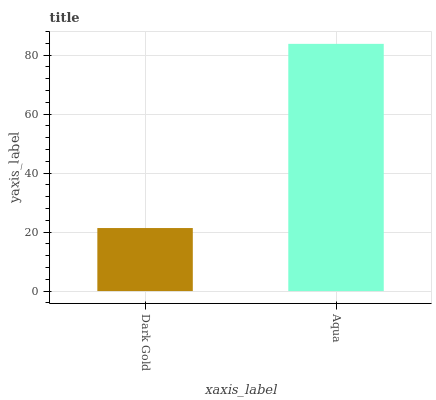Is Dark Gold the minimum?
Answer yes or no. Yes. Is Aqua the maximum?
Answer yes or no. Yes. Is Aqua the minimum?
Answer yes or no. No. Is Aqua greater than Dark Gold?
Answer yes or no. Yes. Is Dark Gold less than Aqua?
Answer yes or no. Yes. Is Dark Gold greater than Aqua?
Answer yes or no. No. Is Aqua less than Dark Gold?
Answer yes or no. No. Is Aqua the high median?
Answer yes or no. Yes. Is Dark Gold the low median?
Answer yes or no. Yes. Is Dark Gold the high median?
Answer yes or no. No. Is Aqua the low median?
Answer yes or no. No. 